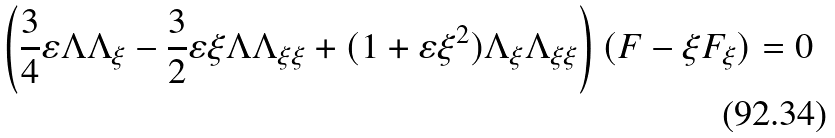<formula> <loc_0><loc_0><loc_500><loc_500>\left ( \frac { 3 } { 4 } \varepsilon \Lambda \Lambda _ { \xi } - \frac { 3 } { 2 } \varepsilon \xi \Lambda \Lambda _ { \xi \xi } + ( 1 + \varepsilon \xi ^ { 2 } ) \Lambda _ { \xi } \Lambda _ { \xi \xi } \right ) ( F - \xi F _ { \xi } ) = 0</formula> 